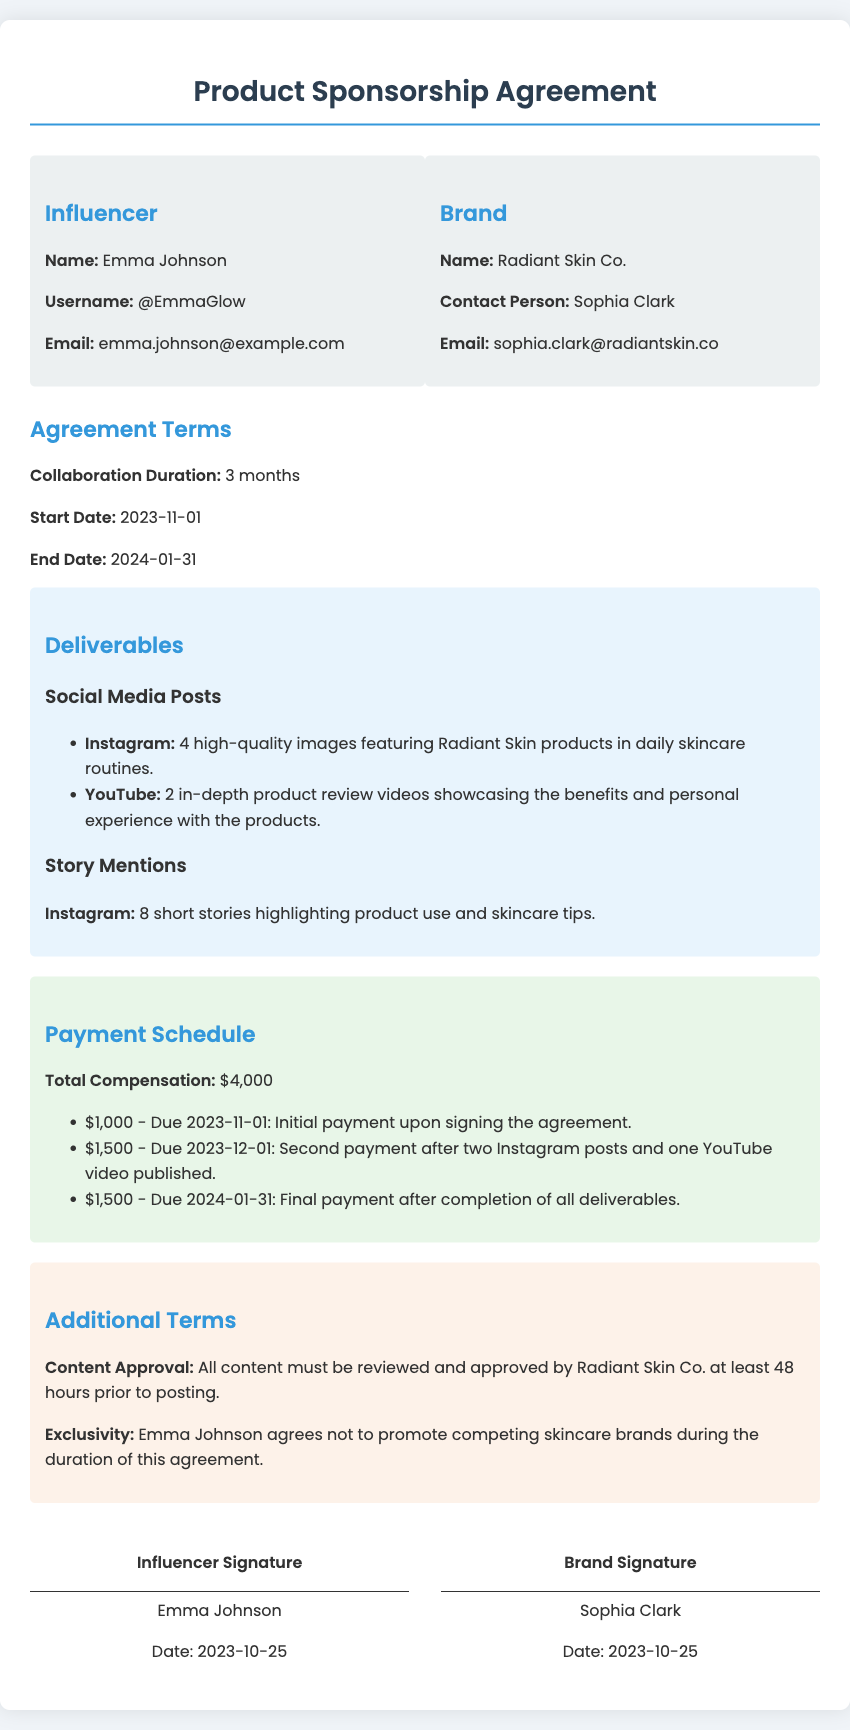What is the influencer's name? The influencer's name is provided in the document under the Influencer section.
Answer: Emma Johnson What is the total compensation? The total compensation is listed in the Payment Schedule section of the document.
Answer: $4,000 When does the collaboration start? The start date of the collaboration is specified in the Agreement Terms section.
Answer: 2023-11-01 How many Instagram posts are required? The number of Instagram posts is mentioned under the Deliverables section in the document.
Answer: 4 What is the final payment amount? The final payment amount is detailed in the Payment Schedule section, specifically for the last payment.
Answer: $1,500 Who is the brand contact person? The brand contact person's name is indicated in the Brand section of the document.
Answer: Sophia Clark What is the exclusivity term? The exclusivity term is explained in the Additional Terms section regarding competing brands.
Answer: Not to promote competing skincare brands How many YouTube videos are required? The required number of YouTube videos is listed under the Deliverables section of the document.
Answer: 2 When is the second payment due? The due date for the second payment is specified in the Payment Schedule section of the document.
Answer: 2023-12-01 